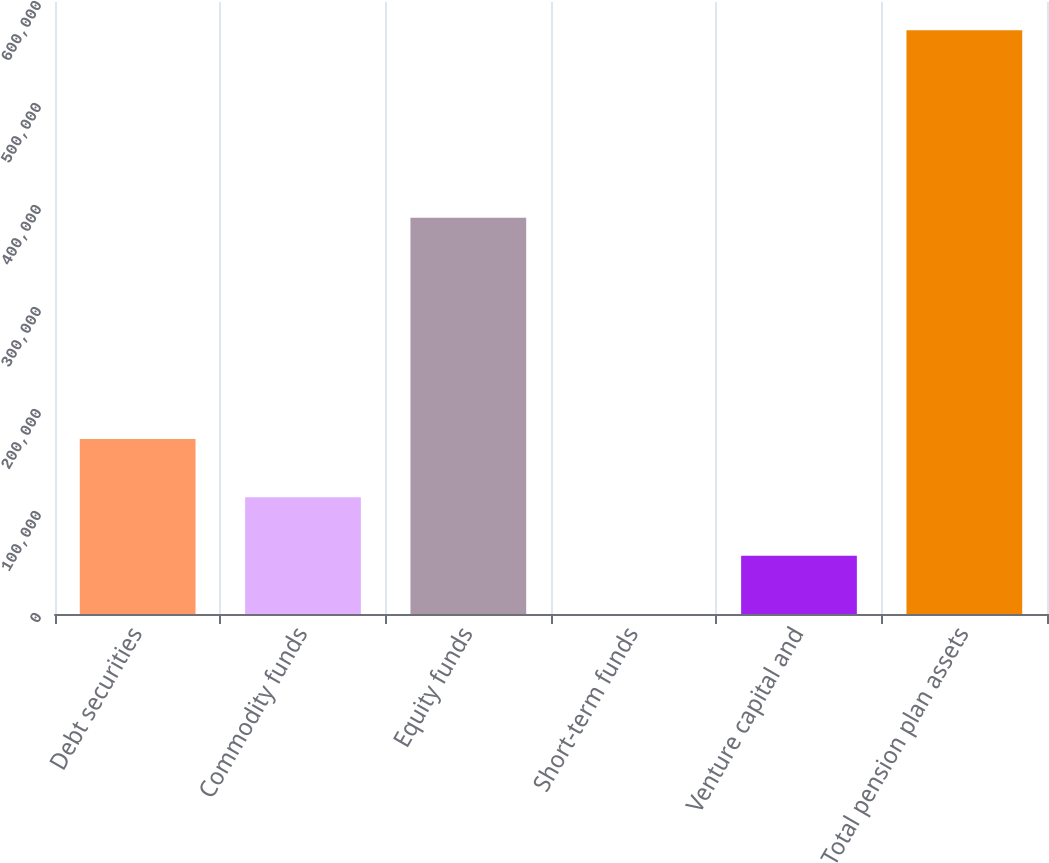Convert chart. <chart><loc_0><loc_0><loc_500><loc_500><bar_chart><fcel>Debt securities<fcel>Commodity funds<fcel>Equity funds<fcel>Short-term funds<fcel>Venture capital and<fcel>Total pension plan assets<nl><fcel>171684<fcel>114456<fcel>388499<fcel>0.22<fcel>57228.1<fcel>572279<nl></chart> 